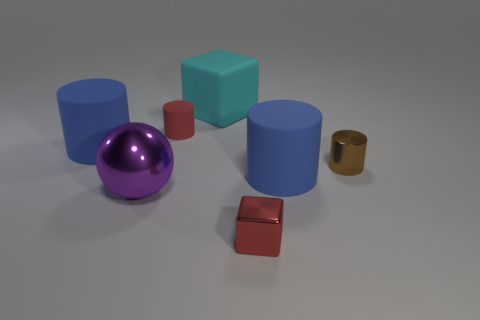Subtract 1 cylinders. How many cylinders are left? 3 Add 1 gray matte objects. How many objects exist? 8 Subtract all blocks. How many objects are left? 5 Add 3 brown cylinders. How many brown cylinders exist? 4 Subtract 0 blue spheres. How many objects are left? 7 Subtract all big gray shiny spheres. Subtract all large cylinders. How many objects are left? 5 Add 2 things. How many things are left? 9 